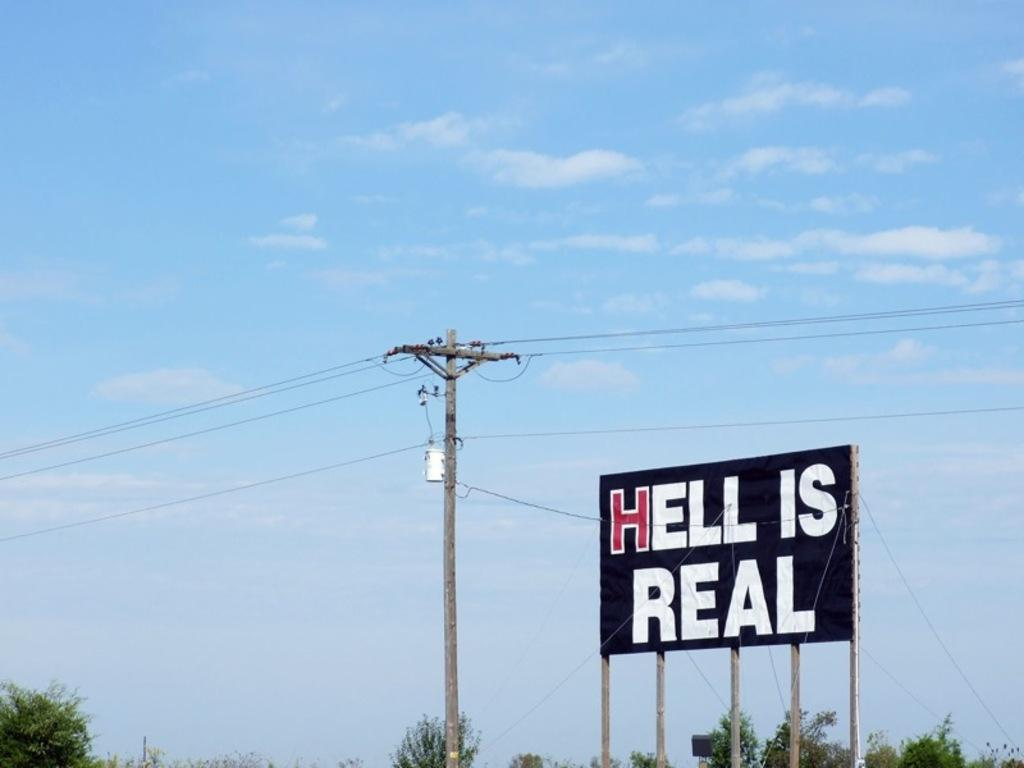<image>
Present a compact description of the photo's key features. black billboard with hell is real on it next to a power pole 